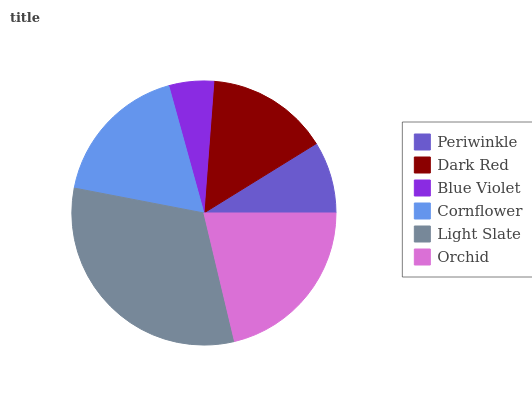Is Blue Violet the minimum?
Answer yes or no. Yes. Is Light Slate the maximum?
Answer yes or no. Yes. Is Dark Red the minimum?
Answer yes or no. No. Is Dark Red the maximum?
Answer yes or no. No. Is Dark Red greater than Periwinkle?
Answer yes or no. Yes. Is Periwinkle less than Dark Red?
Answer yes or no. Yes. Is Periwinkle greater than Dark Red?
Answer yes or no. No. Is Dark Red less than Periwinkle?
Answer yes or no. No. Is Cornflower the high median?
Answer yes or no. Yes. Is Dark Red the low median?
Answer yes or no. Yes. Is Periwinkle the high median?
Answer yes or no. No. Is Blue Violet the low median?
Answer yes or no. No. 